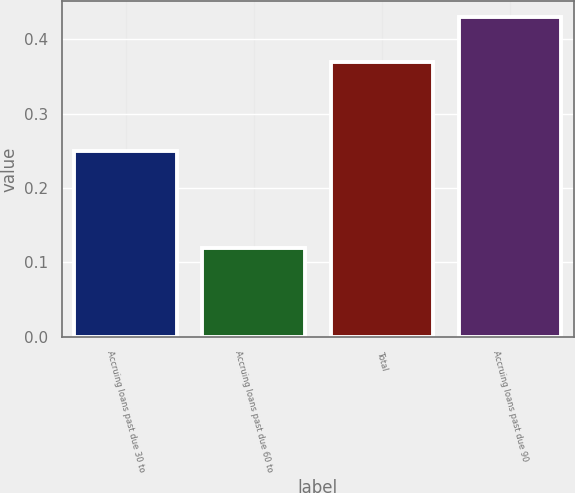<chart> <loc_0><loc_0><loc_500><loc_500><bar_chart><fcel>Accruing loans past due 30 to<fcel>Accruing loans past due 60 to<fcel>Total<fcel>Accruing loans past due 90<nl><fcel>0.25<fcel>0.12<fcel>0.37<fcel>0.43<nl></chart> 